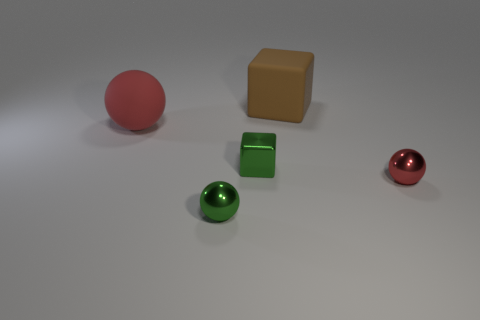Subtract all metallic spheres. How many spheres are left? 1 Add 2 cubes. How many objects exist? 7 Subtract all cubes. How many objects are left? 3 Subtract 0 yellow cylinders. How many objects are left? 5 Subtract all yellow matte cylinders. Subtract all small green spheres. How many objects are left? 4 Add 5 small red balls. How many small red balls are left? 6 Add 4 red things. How many red things exist? 6 